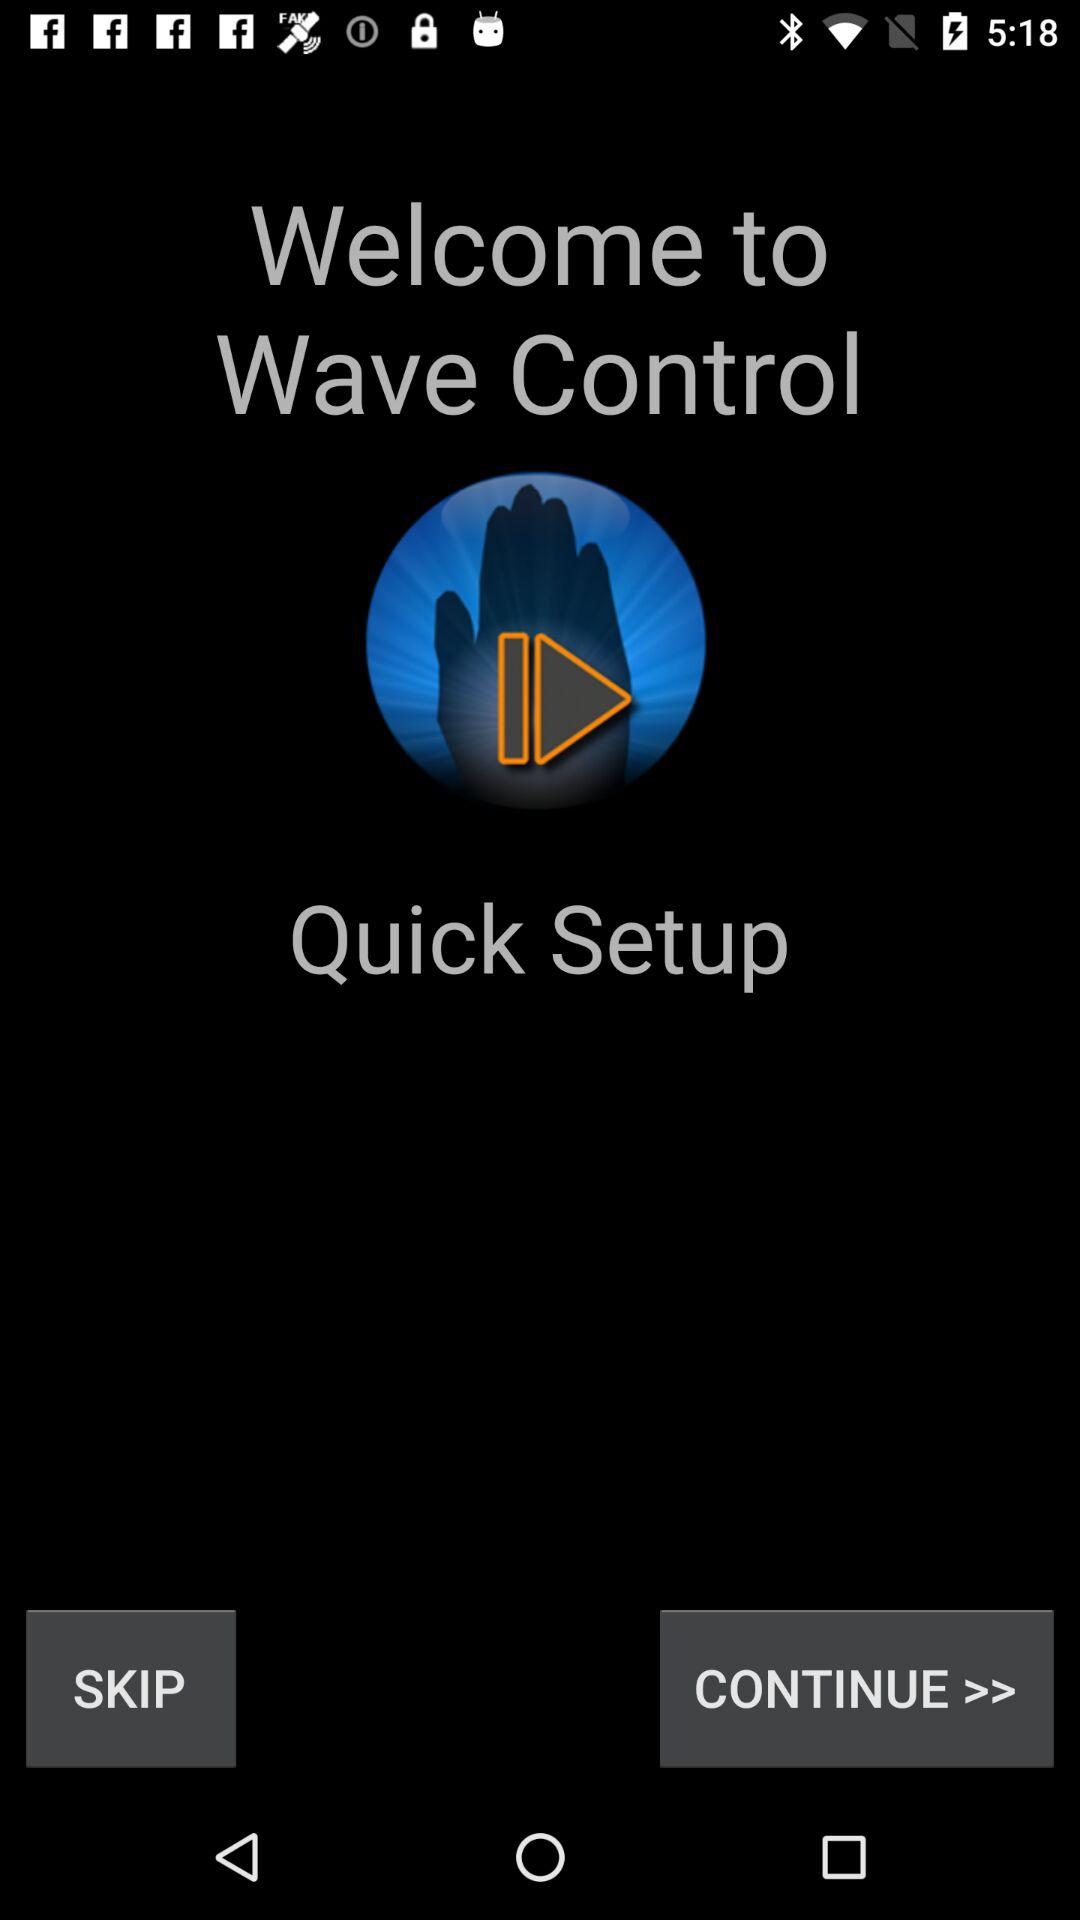What is the name of the application? The application name is "Wave Control". 